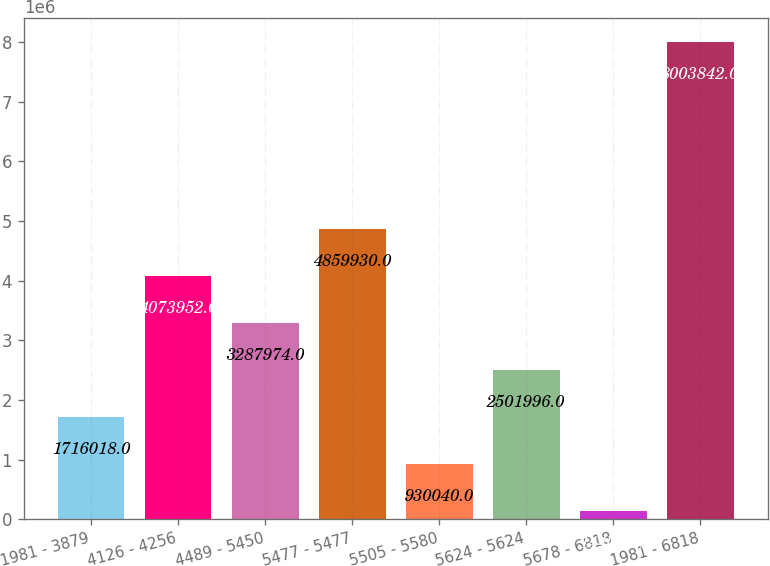<chart> <loc_0><loc_0><loc_500><loc_500><bar_chart><fcel>1981 - 3879<fcel>4126 - 4256<fcel>4489 - 5450<fcel>5477 - 5477<fcel>5505 - 5580<fcel>5624 - 5624<fcel>5678 - 6818<fcel>1981 - 6818<nl><fcel>1.71602e+06<fcel>4.07395e+06<fcel>3.28797e+06<fcel>4.85993e+06<fcel>930040<fcel>2.502e+06<fcel>144062<fcel>8.00384e+06<nl></chart> 